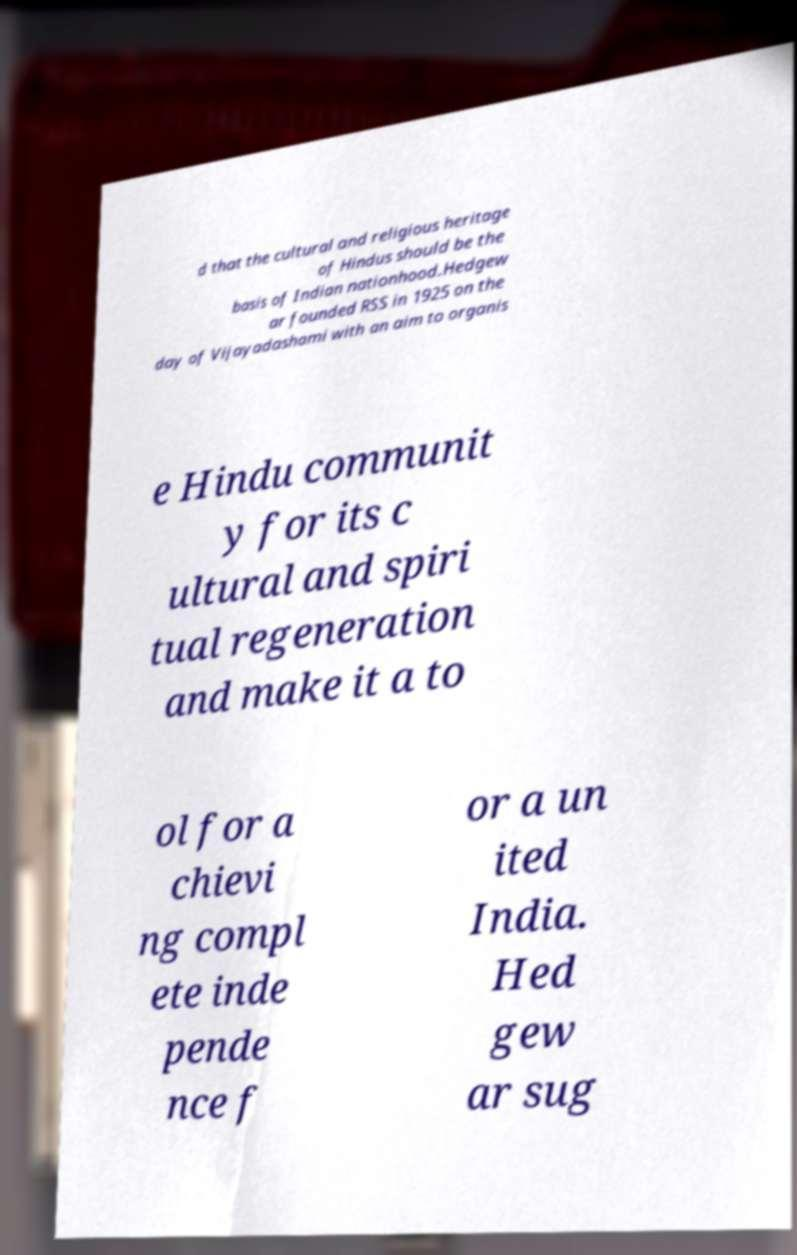Could you extract and type out the text from this image? d that the cultural and religious heritage of Hindus should be the basis of Indian nationhood.Hedgew ar founded RSS in 1925 on the day of Vijayadashami with an aim to organis e Hindu communit y for its c ultural and spiri tual regeneration and make it a to ol for a chievi ng compl ete inde pende nce f or a un ited India. Hed gew ar sug 